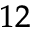<formula> <loc_0><loc_0><loc_500><loc_500>_ { 1 2 }</formula> 